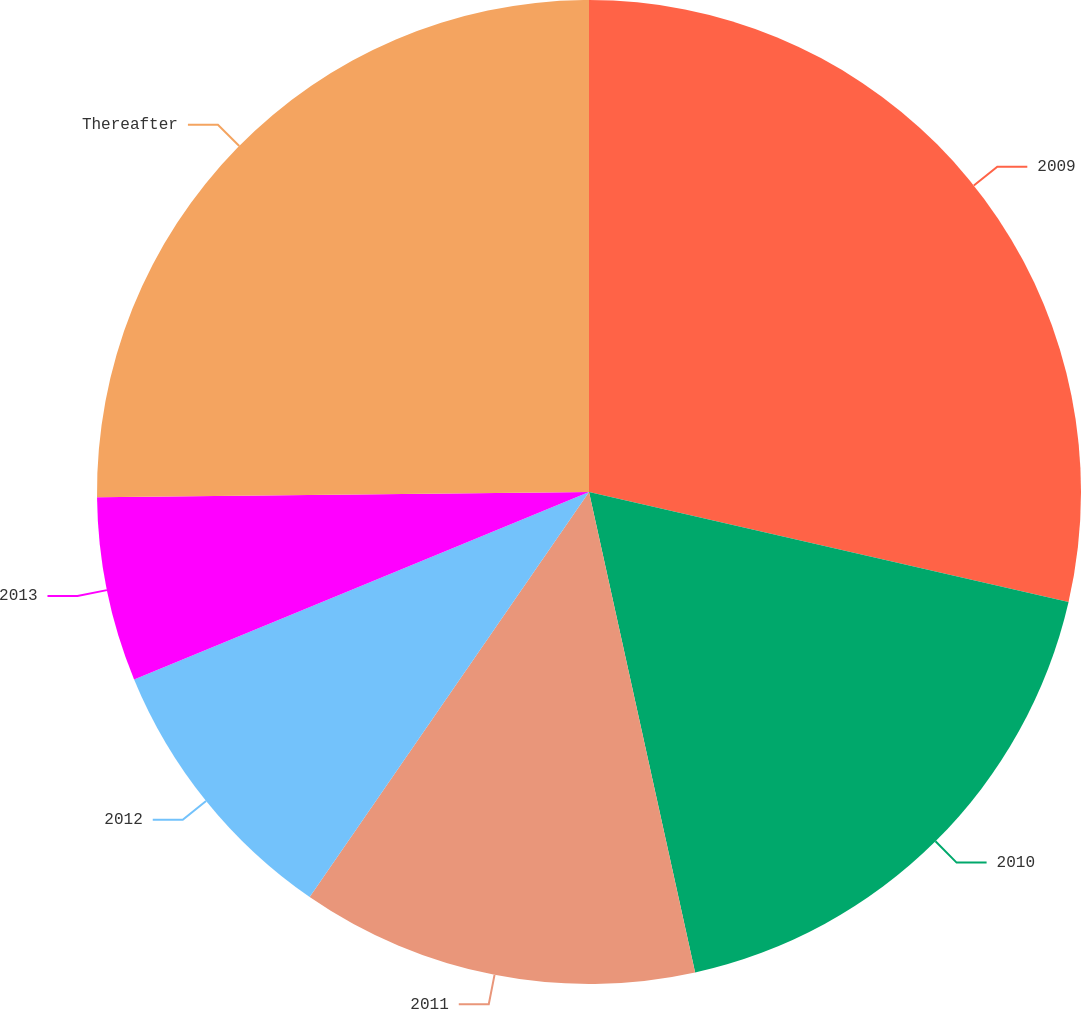Convert chart. <chart><loc_0><loc_0><loc_500><loc_500><pie_chart><fcel>2009<fcel>2010<fcel>2011<fcel>2012<fcel>2013<fcel>Thereafter<nl><fcel>28.59%<fcel>17.95%<fcel>13.07%<fcel>9.17%<fcel>6.05%<fcel>25.17%<nl></chart> 